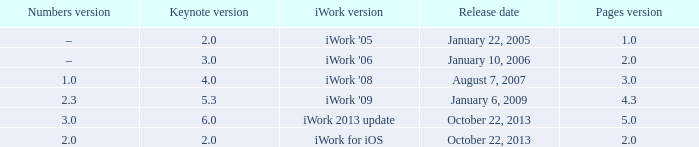What version of iWork was released on October 22, 2013 with a pages version greater than 2? Iwork 2013 update. Parse the table in full. {'header': ['Numbers version', 'Keynote version', 'iWork version', 'Release date', 'Pages version'], 'rows': [['–', '2.0', "iWork '05", 'January 22, 2005', '1.0'], ['–', '3.0', "iWork '06", 'January 10, 2006', '2.0'], ['1.0', '4.0', "iWork '08", 'August 7, 2007', '3.0'], ['2.3', '5.3', "iWork '09", 'January 6, 2009', '4.3'], ['3.0', '6.0', 'iWork 2013 update', 'October 22, 2013', '5.0'], ['2.0', '2.0', 'iWork for iOS', 'October 22, 2013', '2.0']]} 